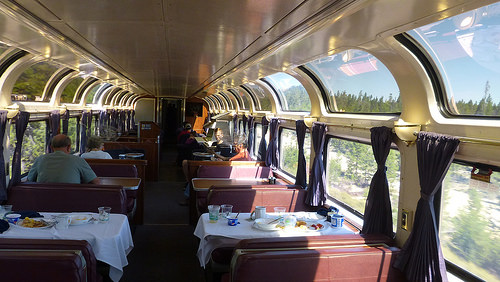<image>
Is there a glass on the table? No. The glass is not positioned on the table. They may be near each other, but the glass is not supported by or resting on top of the table. 